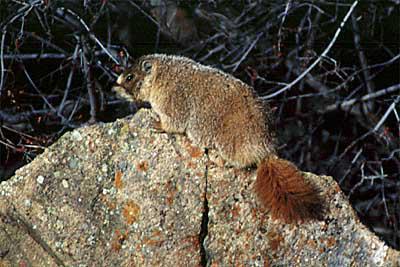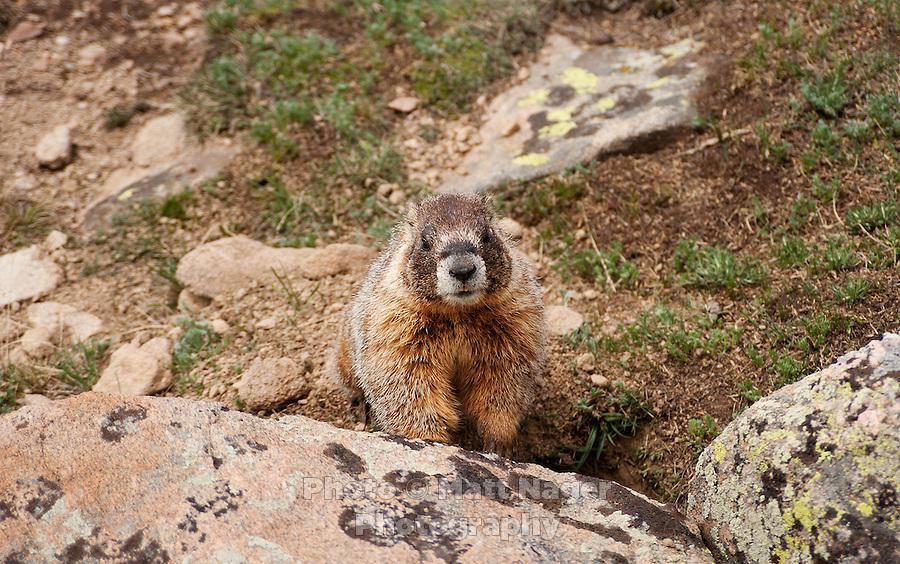The first image is the image on the left, the second image is the image on the right. For the images shown, is this caption "An image shows a marmot posed on all fours on a rock, and the image contains only one rock." true? Answer yes or no. Yes. The first image is the image on the left, the second image is the image on the right. For the images displayed, is the sentence "A type of rodent is sitting on a rock with both front legs up in the air." factually correct? Answer yes or no. No. 